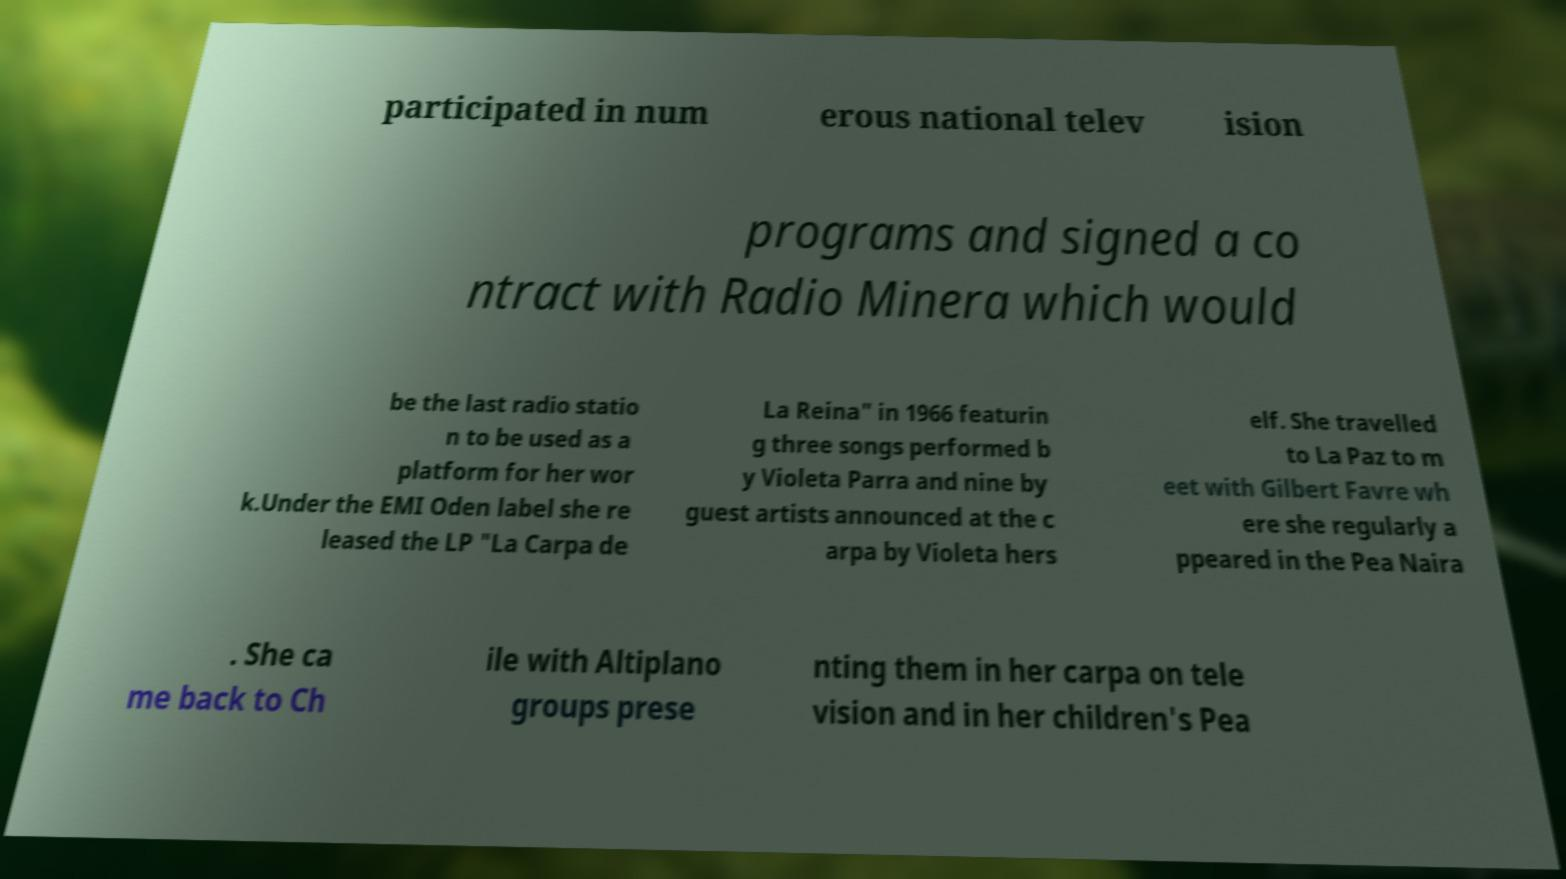Could you extract and type out the text from this image? participated in num erous national telev ision programs and signed a co ntract with Radio Minera which would be the last radio statio n to be used as a platform for her wor k.Under the EMI Oden label she re leased the LP "La Carpa de La Reina" in 1966 featurin g three songs performed b y Violeta Parra and nine by guest artists announced at the c arpa by Violeta hers elf. She travelled to La Paz to m eet with Gilbert Favre wh ere she regularly a ppeared in the Pea Naira . She ca me back to Ch ile with Altiplano groups prese nting them in her carpa on tele vision and in her children's Pea 